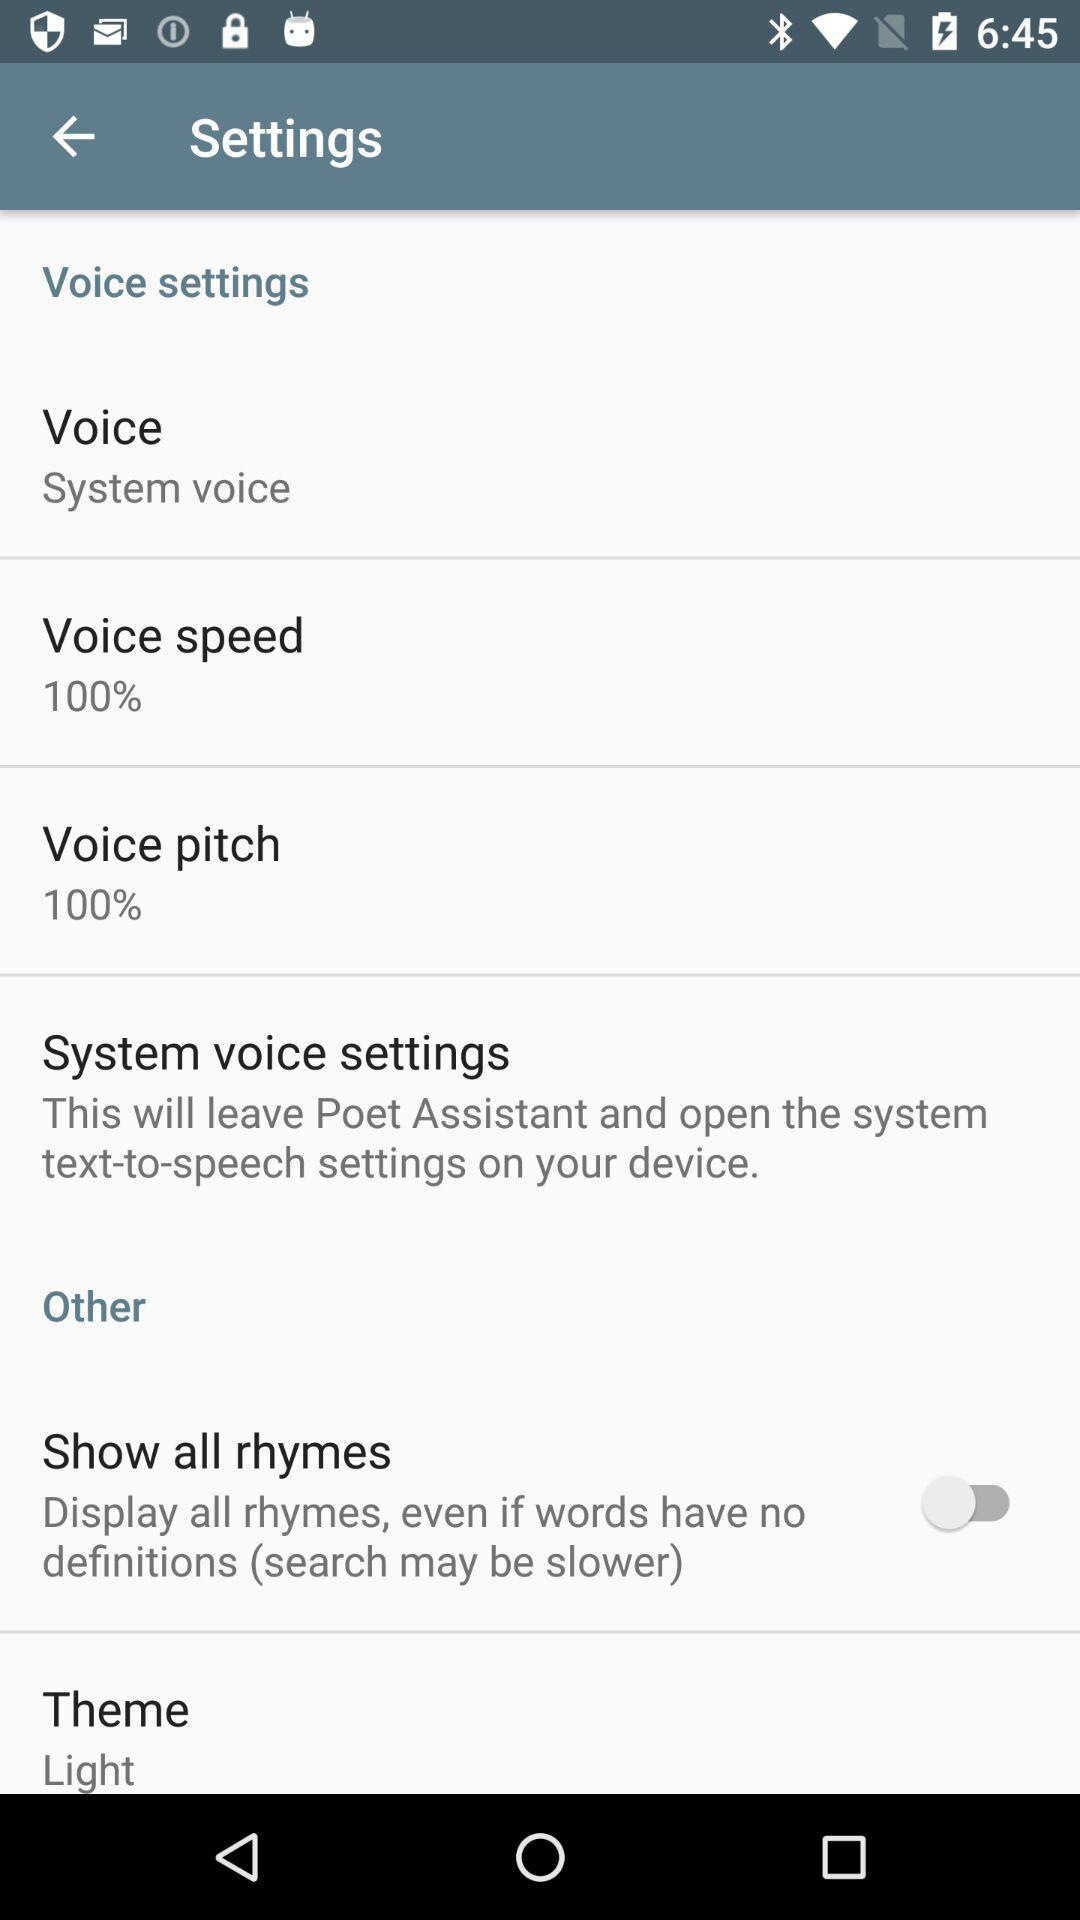What is the setting for the voice? The setting for the voice is "System voice". 